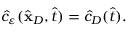Convert formula to latex. <formula><loc_0><loc_0><loc_500><loc_500>\begin{array} { r } { \hat { c } _ { \varepsilon } ( \hat { \mathbf x } _ { D } , \hat { t } ) = \hat { c } _ { D } ( \hat { t } ) . } \end{array}</formula> 